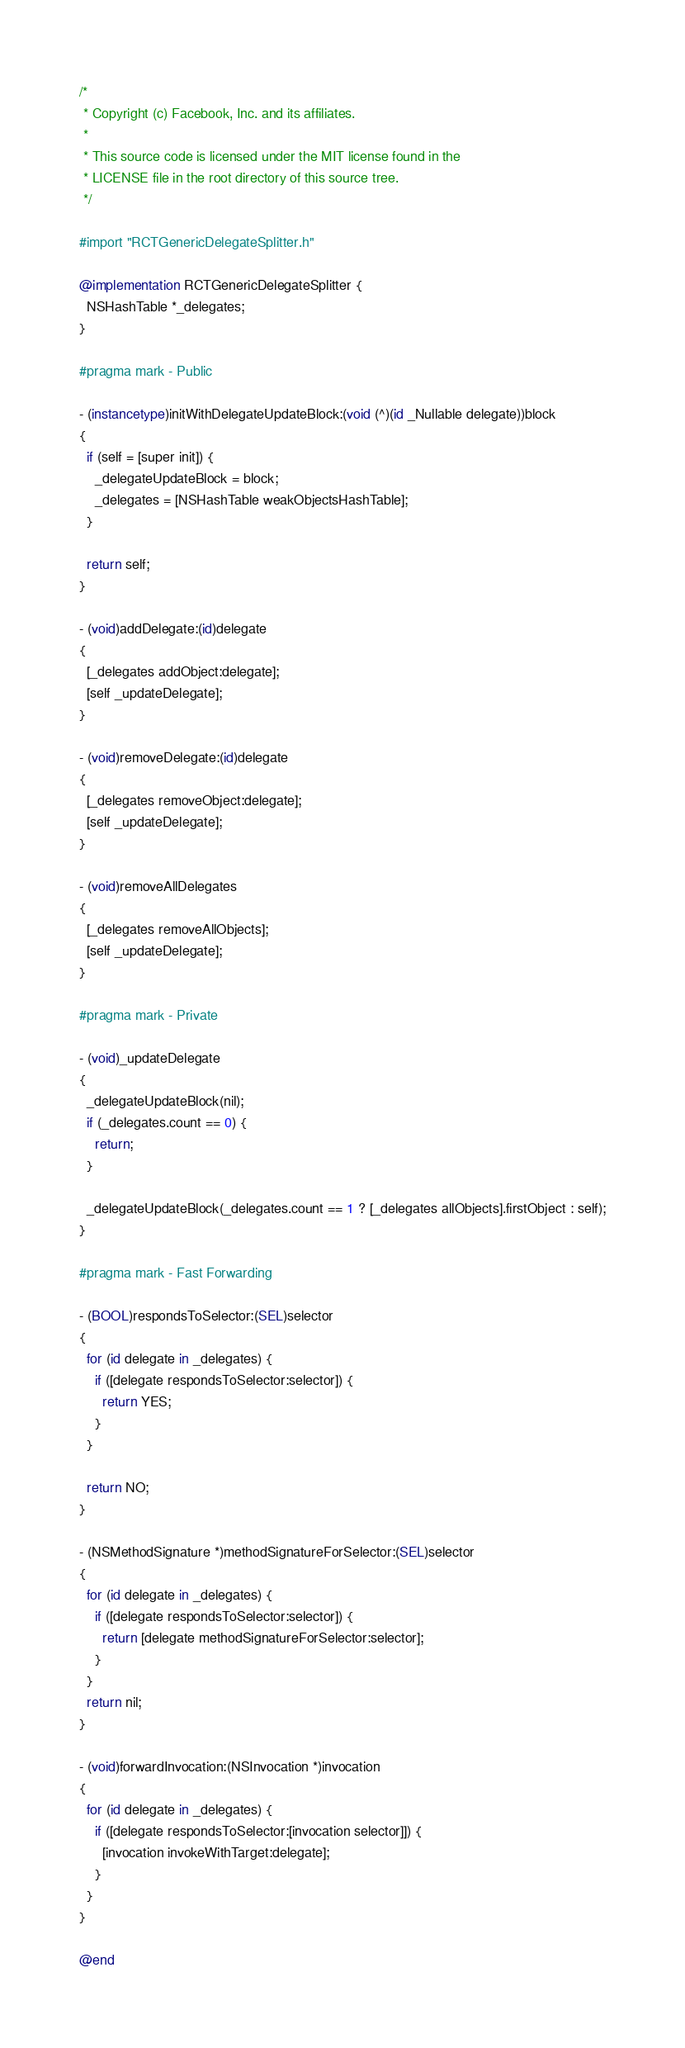<code> <loc_0><loc_0><loc_500><loc_500><_ObjectiveC_>/*
 * Copyright (c) Facebook, Inc. and its affiliates.
 *
 * This source code is licensed under the MIT license found in the
 * LICENSE file in the root directory of this source tree.
 */

#import "RCTGenericDelegateSplitter.h"

@implementation RCTGenericDelegateSplitter {
  NSHashTable *_delegates;
}

#pragma mark - Public

- (instancetype)initWithDelegateUpdateBlock:(void (^)(id _Nullable delegate))block
{
  if (self = [super init]) {
    _delegateUpdateBlock = block;
    _delegates = [NSHashTable weakObjectsHashTable];
  }

  return self;
}

- (void)addDelegate:(id)delegate
{
  [_delegates addObject:delegate];
  [self _updateDelegate];
}

- (void)removeDelegate:(id)delegate
{
  [_delegates removeObject:delegate];
  [self _updateDelegate];
}

- (void)removeAllDelegates
{
  [_delegates removeAllObjects];
  [self _updateDelegate];
}

#pragma mark - Private

- (void)_updateDelegate
{
  _delegateUpdateBlock(nil);
  if (_delegates.count == 0) {
    return;
  }

  _delegateUpdateBlock(_delegates.count == 1 ? [_delegates allObjects].firstObject : self);
}

#pragma mark - Fast Forwarding

- (BOOL)respondsToSelector:(SEL)selector
{
  for (id delegate in _delegates) {
    if ([delegate respondsToSelector:selector]) {
      return YES;
    }
  }

  return NO;
}

- (NSMethodSignature *)methodSignatureForSelector:(SEL)selector
{
  for (id delegate in _delegates) {
    if ([delegate respondsToSelector:selector]) {
      return [delegate methodSignatureForSelector:selector];
    }
  }
  return nil;
}

- (void)forwardInvocation:(NSInvocation *)invocation
{
  for (id delegate in _delegates) {
    if ([delegate respondsToSelector:[invocation selector]]) {
      [invocation invokeWithTarget:delegate];
    }
  }
}

@end
</code> 